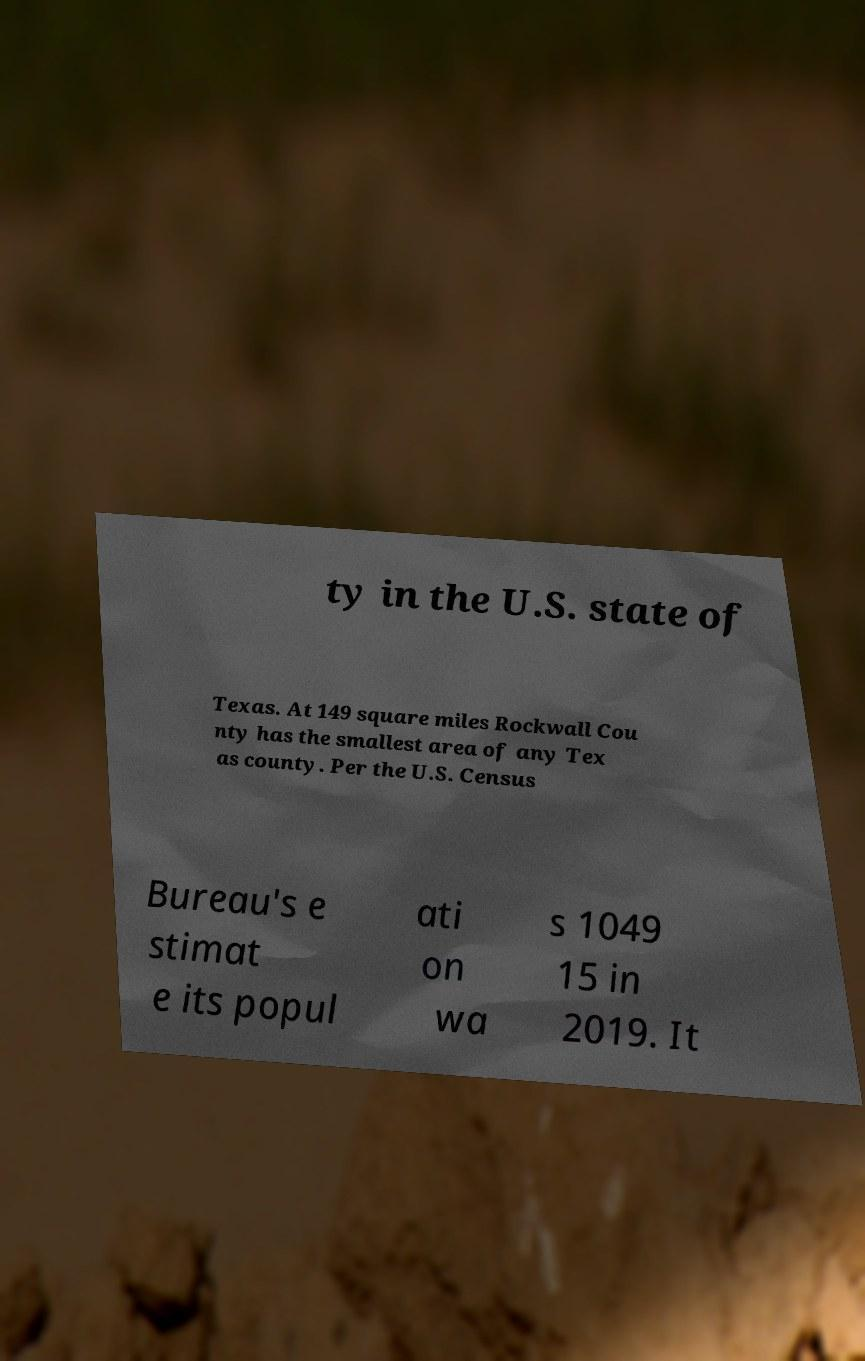There's text embedded in this image that I need extracted. Can you transcribe it verbatim? ty in the U.S. state of Texas. At 149 square miles Rockwall Cou nty has the smallest area of any Tex as county. Per the U.S. Census Bureau's e stimat e its popul ati on wa s 1049 15 in 2019. It 